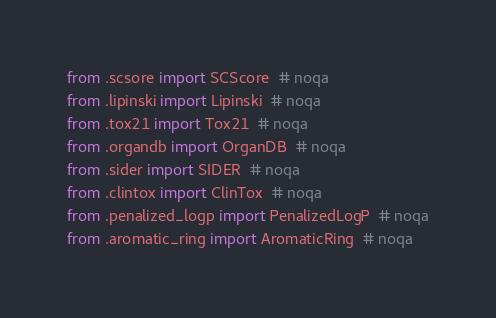Convert code to text. <code><loc_0><loc_0><loc_500><loc_500><_Python_>from .scsore import SCScore  # noqa
from .lipinski import Lipinski  # noqa
from .tox21 import Tox21  # noqa
from .organdb import OrganDB  # noqa
from .sider import SIDER  # noqa
from .clintox import ClinTox  # noqa
from .penalized_logp import PenalizedLogP  # noqa
from .aromatic_ring import AromaticRing  # noqa
</code> 